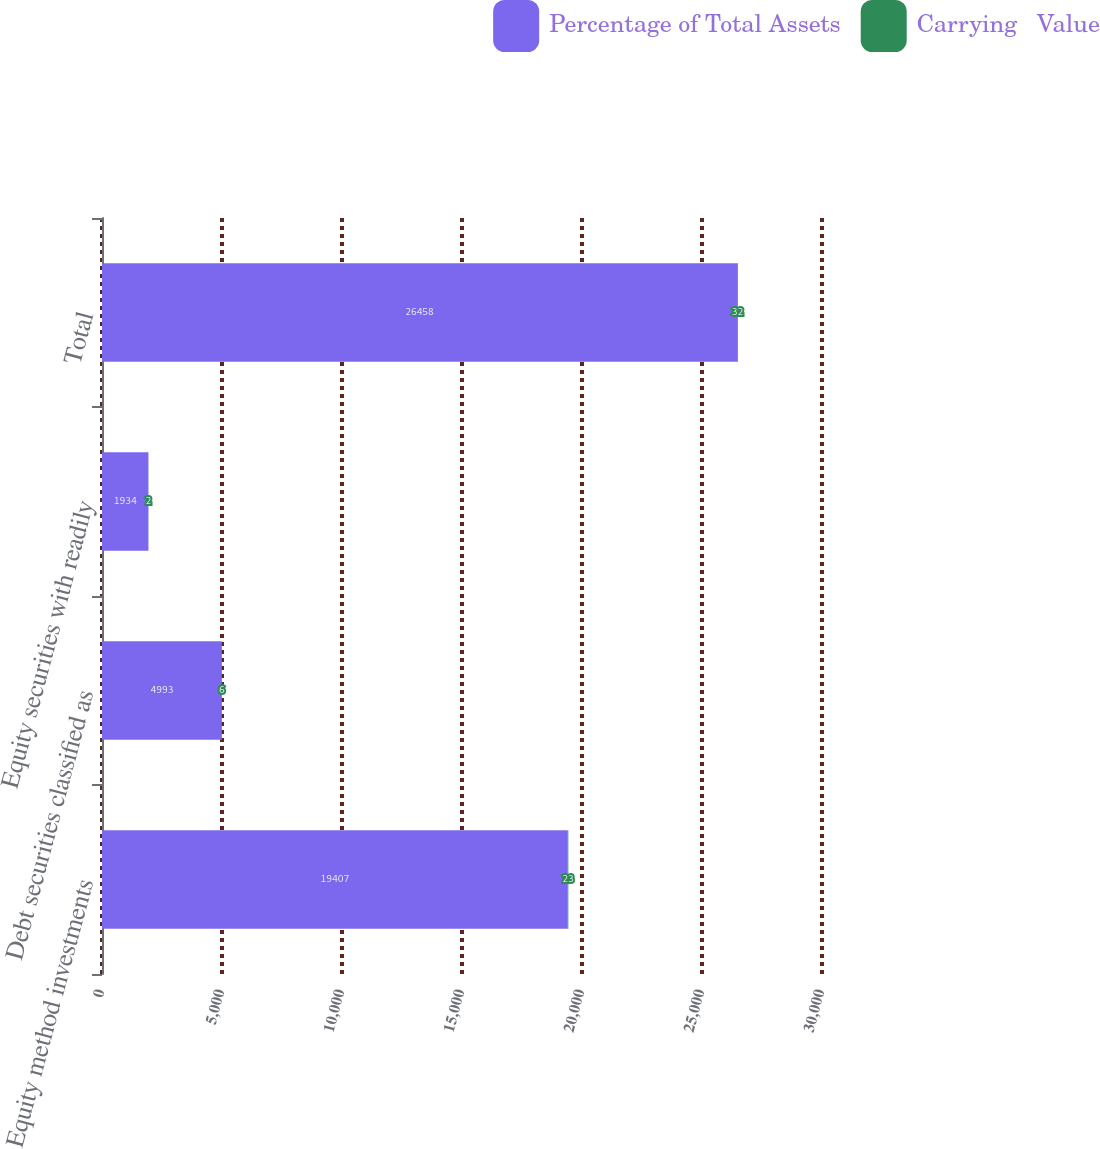Convert chart. <chart><loc_0><loc_0><loc_500><loc_500><stacked_bar_chart><ecel><fcel>Equity method investments<fcel>Debt securities classified as<fcel>Equity securities with readily<fcel>Total<nl><fcel>Percentage of Total Assets<fcel>19407<fcel>4993<fcel>1934<fcel>26458<nl><fcel>Carrying   Value<fcel>23<fcel>6<fcel>2<fcel>32<nl></chart> 